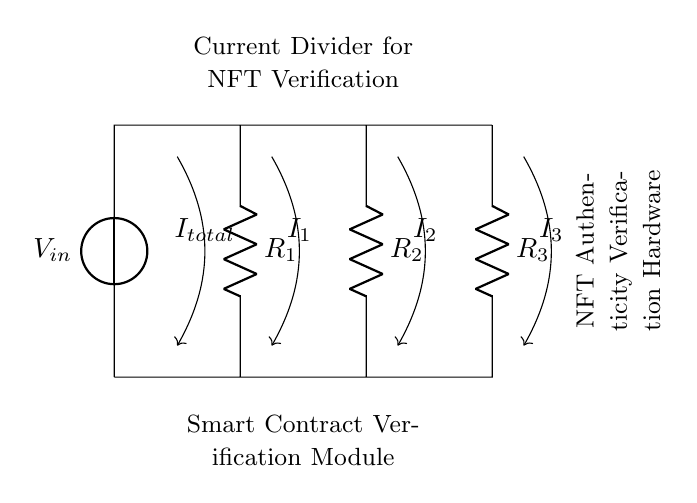What is the input voltage in this circuit? The input voltage is labeled as V_in at the left side of the circuit.
Answer: V_in What are the values of the resistors? The resistors are labeled R_1, R_2, and R_3, with no specific numerical values given in the diagram.
Answer: R_1, R_2, R_3 What type of circuit is this? This circuit is a current divider, which distributes the input current through parallel resistors.
Answer: Current divider How many branches does this current divider have? The current divider has three branches, represented by the three resistors R_1, R_2, and R_3.
Answer: Three What is the primary function of the current divider in this context? The current divider is used for NFT authenticity verification, distributing current for the smart contract verification module.
Answer: NFT verification Which component receives the total current from the input? The voltage source labeled V_in supplies the total current entering the circuit through the initial branch.
Answer: Voltage source What labels indicate the currents flowing through each branch? The labels I_1, I_2, and I_3 are used for the currents in the respective branches of the circuit.
Answer: I_1, I_2, I_3 